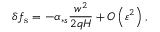<formula> <loc_0><loc_0><loc_500><loc_500>\delta f _ { s } = - \alpha _ { \ast s } \frac { w ^ { 2 } } { 2 q H } + O \left ( \varepsilon ^ { 2 } \right ) ,</formula> 